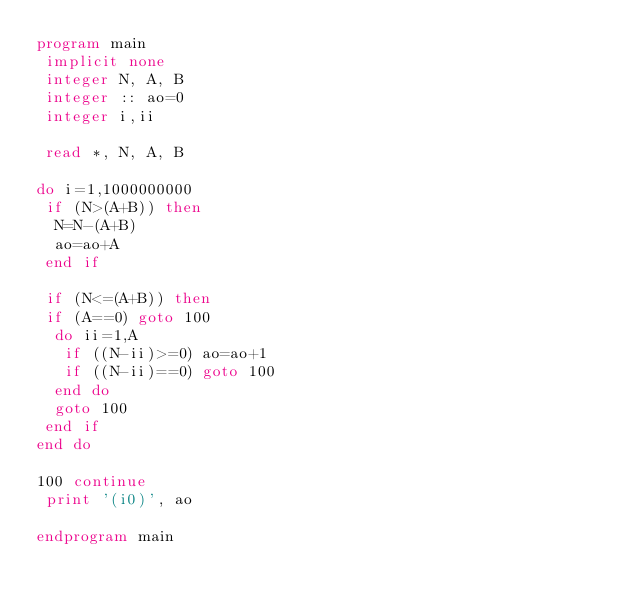Convert code to text. <code><loc_0><loc_0><loc_500><loc_500><_FORTRAN_>program main
 implicit none
 integer N, A, B
 integer :: ao=0
 integer i,ii

 read *, N, A, B

do i=1,1000000000
 if (N>(A+B)) then
  N=N-(A+B)
  ao=ao+A
 end if

 if (N<=(A+B)) then
 if (A==0) goto 100
  do ii=1,A
   if ((N-ii)>=0) ao=ao+1
   if ((N-ii)==0) goto 100
  end do
  goto 100
 end if
end do

100 continue
 print '(i0)', ao

endprogram main
</code> 